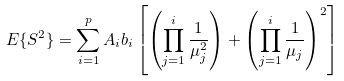Convert formula to latex. <formula><loc_0><loc_0><loc_500><loc_500>E \{ S ^ { 2 } \} = \sum _ { i = 1 } ^ { p } A _ { i } b _ { i } \left [ \left ( \prod _ { j = 1 } ^ { i } \frac { 1 } { \mu _ { j } ^ { 2 } } \right ) + \left ( \prod _ { j = 1 } ^ { i } \frac { 1 } { \mu _ { j } } \right ) ^ { 2 } \right ]</formula> 